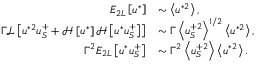Convert formula to latex. <formula><loc_0><loc_0><loc_500><loc_500>\begin{array} { r l } { E _ { 2 L } \left [ u ^ { * } \right ] } & { \sim \left < u ^ { * 2 } \right > , } \\ { \Gamma \mathcal { L } \left [ u ^ { * 2 } u _ { S } ^ { + } + \mathcal { H } \left [ u ^ { * } \right ] \mathcal { H } \left [ u ^ { * } u _ { S } ^ { + } \right ] \right ] } & { \sim \Gamma \left < u _ { S } ^ { + 2 } \right > ^ { 1 / 2 } \left < u ^ { * 2 } \right > , } \\ { \Gamma ^ { 2 } E _ { 2 L } \left [ u ^ { * } u _ { S } ^ { + } \right ] } & { \sim \Gamma ^ { 2 } \left < u _ { S } ^ { + 2 } \right > \left < u ^ { * 2 } \right > . } \end{array}</formula> 